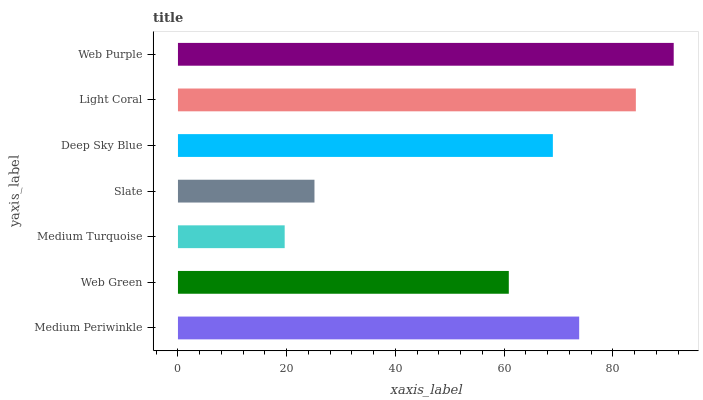Is Medium Turquoise the minimum?
Answer yes or no. Yes. Is Web Purple the maximum?
Answer yes or no. Yes. Is Web Green the minimum?
Answer yes or no. No. Is Web Green the maximum?
Answer yes or no. No. Is Medium Periwinkle greater than Web Green?
Answer yes or no. Yes. Is Web Green less than Medium Periwinkle?
Answer yes or no. Yes. Is Web Green greater than Medium Periwinkle?
Answer yes or no. No. Is Medium Periwinkle less than Web Green?
Answer yes or no. No. Is Deep Sky Blue the high median?
Answer yes or no. Yes. Is Deep Sky Blue the low median?
Answer yes or no. Yes. Is Medium Turquoise the high median?
Answer yes or no. No. Is Light Coral the low median?
Answer yes or no. No. 